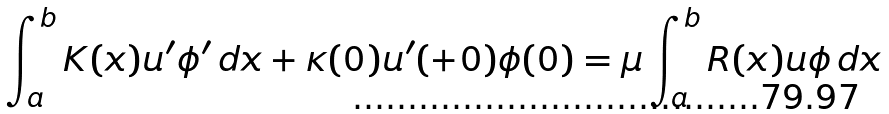<formula> <loc_0><loc_0><loc_500><loc_500>\int _ { a } ^ { b } K ( x ) u ^ { \prime } \phi ^ { \prime } \, d x + \kappa ( 0 ) u ^ { \prime } ( + 0 ) \phi ( 0 ) = \mu \int _ { a } ^ { b } R ( x ) u \phi \, d x</formula> 